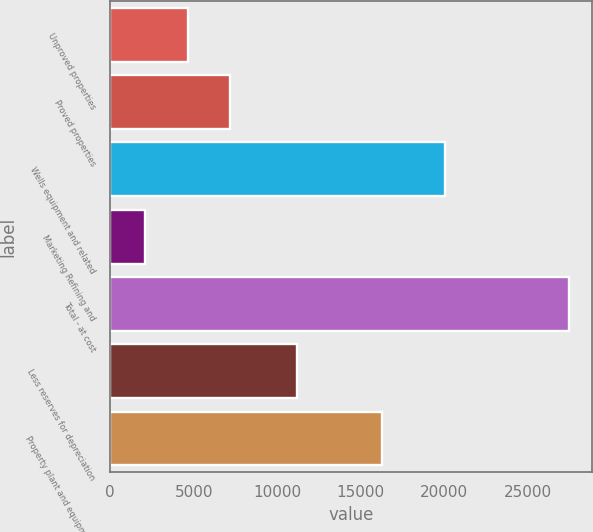Convert chart to OTSL. <chart><loc_0><loc_0><loc_500><loc_500><bar_chart><fcel>Unproved properties<fcel>Proved properties<fcel>Wells equipment and related<fcel>Marketing Refining and<fcel>Total - at cost<fcel>Less reserves for depreciation<fcel>Property plant and equipment -<nl><fcel>4638.2<fcel>7171.4<fcel>20058<fcel>2105<fcel>27437<fcel>11166<fcel>16271<nl></chart> 